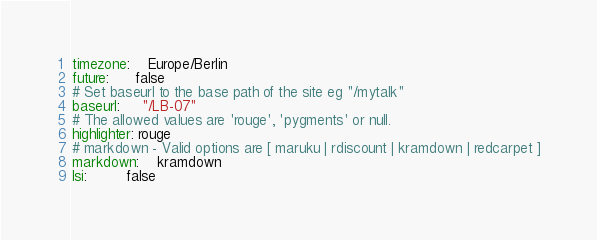<code> <loc_0><loc_0><loc_500><loc_500><_YAML_>timezone:    Europe/Berlin
future:      false
# Set baseurl to the base path of the site eg "/mytalk"
baseurl:     "/LB-07"
# The allowed values are 'rouge', 'pygments' or null.
highlighter: rouge
# markdown - Valid options are [ maruku | rdiscount | kramdown | redcarpet ]
markdown:    kramdown
lsi:         false</code> 